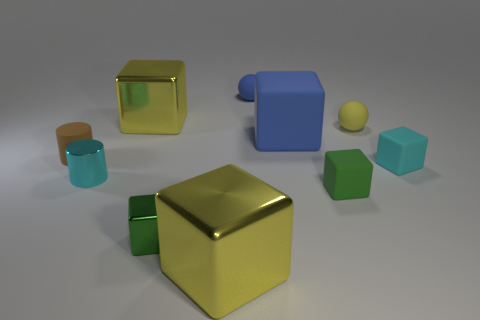What is the material of the tiny cyan object to the right of the blue rubber object in front of the tiny yellow rubber thing?
Offer a very short reply. Rubber. Is the number of blue objects that are left of the brown rubber object less than the number of gray rubber cubes?
Make the answer very short. No. What shape is the green object that is the same material as the cyan block?
Ensure brevity in your answer.  Cube. What number of other things are the same shape as the large rubber object?
Keep it short and to the point. 5. How many gray things are either small matte cubes or metallic blocks?
Your response must be concise. 0. Is the shape of the brown rubber object the same as the tiny cyan metal thing?
Your answer should be very brief. Yes. There is a small cyan object to the right of the tiny cyan shiny thing; are there any small cyan shiny objects behind it?
Keep it short and to the point. No. Are there the same number of small cyan shiny cylinders that are behind the blue ball and big metallic balls?
Provide a succinct answer. Yes. How many other things are the same size as the cyan rubber object?
Ensure brevity in your answer.  6. Is the green thing on the right side of the big matte object made of the same material as the yellow object that is to the right of the small blue rubber object?
Make the answer very short. Yes. 